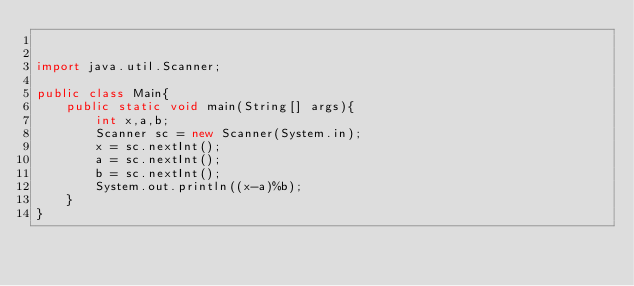Convert code to text. <code><loc_0><loc_0><loc_500><loc_500><_Java_>

import java.util.Scanner;

public class Main{
    public static void main(String[] args){
        int x,a,b;
        Scanner sc = new Scanner(System.in);
        x = sc.nextInt();
        a = sc.nextInt();
        b = sc.nextInt();
        System.out.println((x-a)%b);
    }
}</code> 